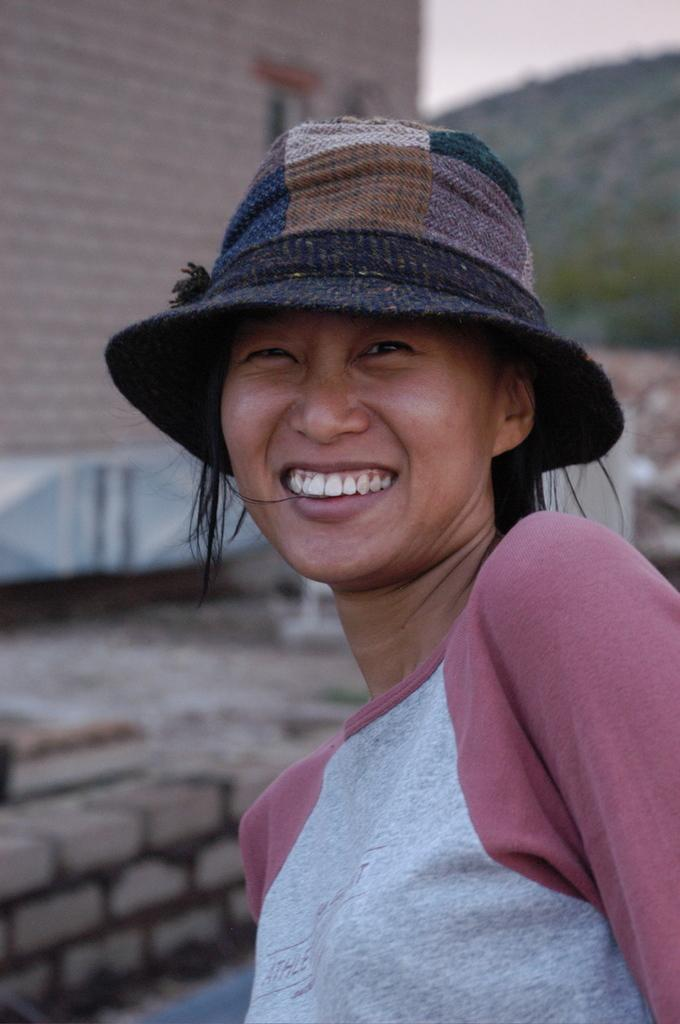What is the main subject of the image? There is a person in the image. Can you describe the person's attire? The person is wearing an ash and maroon color dress. What accessory is the person wearing? The person is wearing a hat. What is the person's facial expression? The person is smiling. What can be seen in the background of the image? There is a wall, mountains, and the sky visible in the background of the image. What type of pipe can be seen in the person's hand in the image? There is no pipe present in the person's hand or anywhere in the image. 